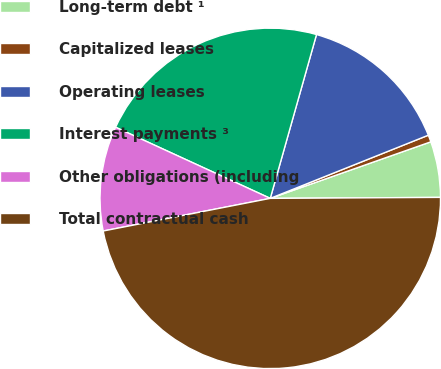<chart> <loc_0><loc_0><loc_500><loc_500><pie_chart><fcel>Long-term debt ¹<fcel>Capitalized leases<fcel>Operating leases<fcel>Interest payments ³<fcel>Other obligations (including<fcel>Total contractual cash<nl><fcel>5.3%<fcel>0.66%<fcel>14.57%<fcel>22.52%<fcel>9.93%<fcel>47.02%<nl></chart> 